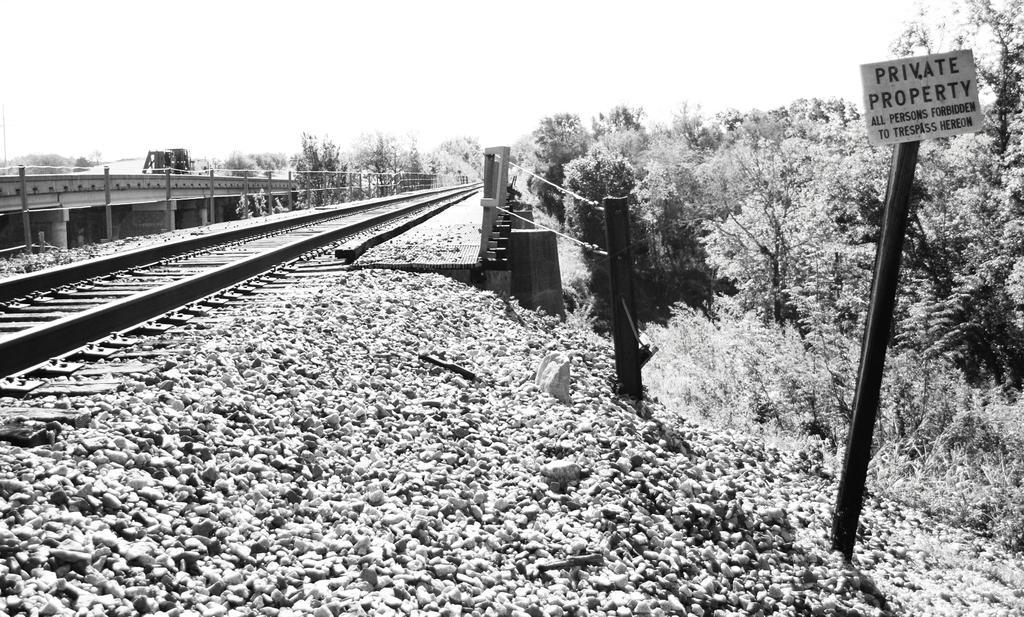In one or two sentences, can you explain what this image depicts? On the left side of the image there is a railway track and we can see a bridge. In the background there are trees and sky. On the right there is a board and we can see stones. 